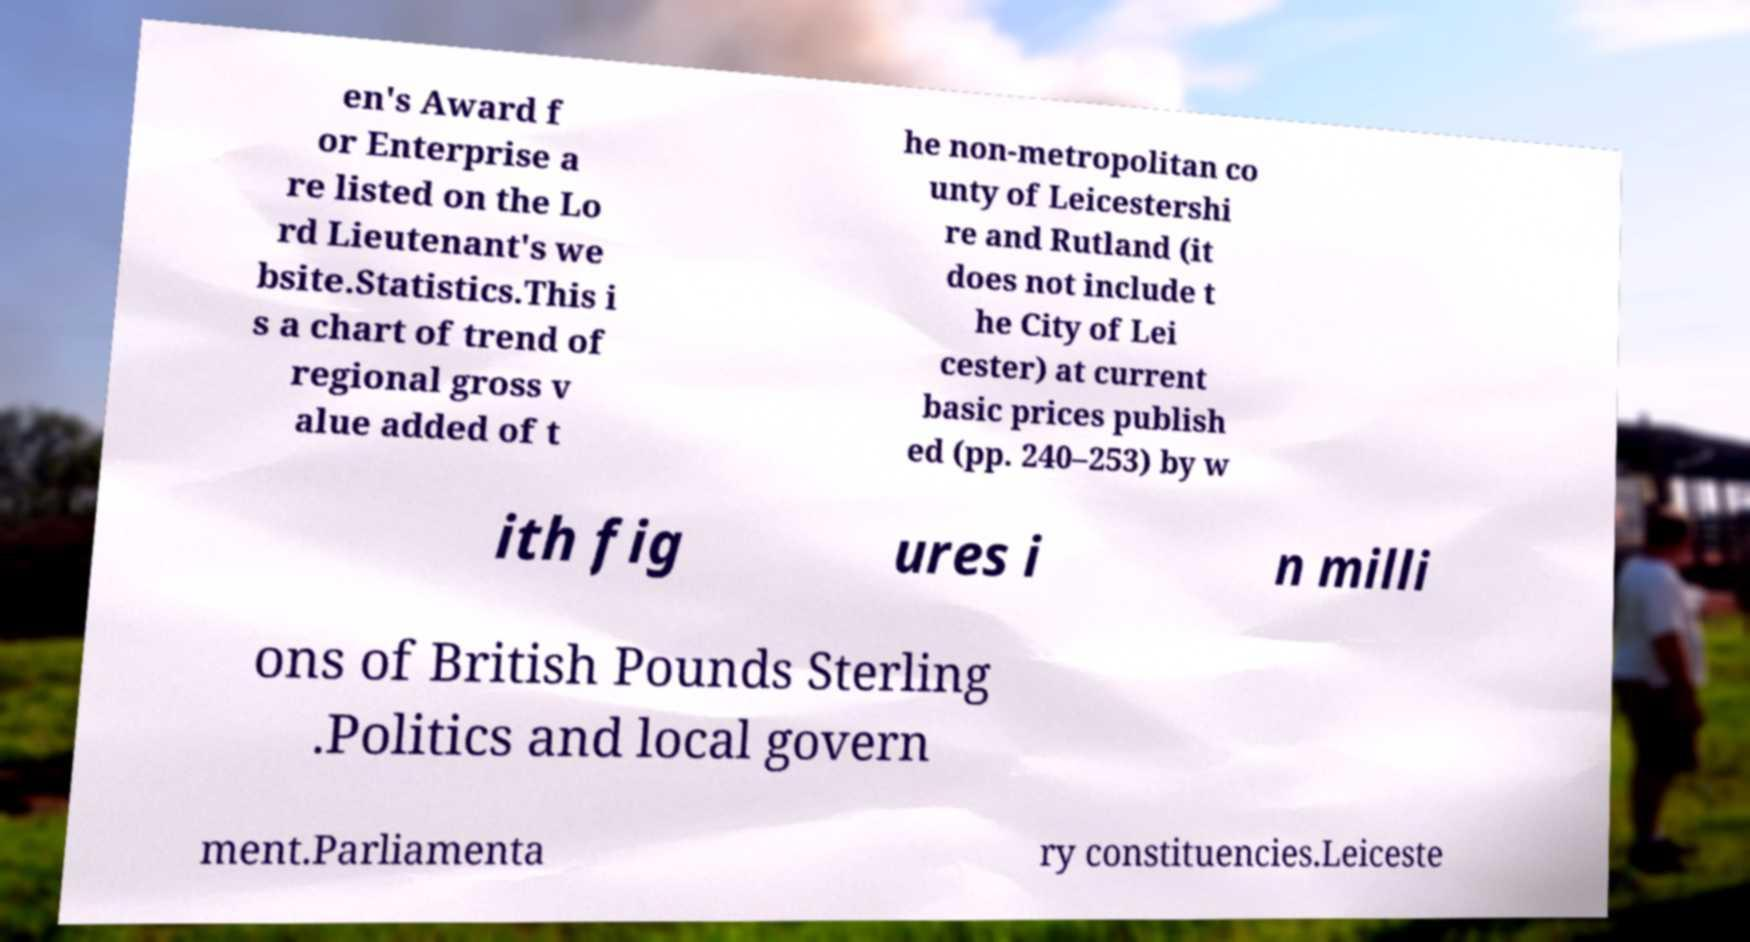Please identify and transcribe the text found in this image. en's Award f or Enterprise a re listed on the Lo rd Lieutenant's we bsite.Statistics.This i s a chart of trend of regional gross v alue added of t he non-metropolitan co unty of Leicestershi re and Rutland (it does not include t he City of Lei cester) at current basic prices publish ed (pp. 240–253) by w ith fig ures i n milli ons of British Pounds Sterling .Politics and local govern ment.Parliamenta ry constituencies.Leiceste 